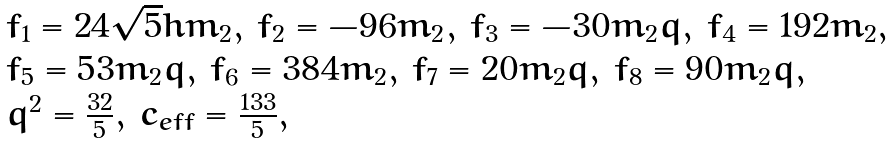<formula> <loc_0><loc_0><loc_500><loc_500>\begin{array} { l } f _ { 1 } = 2 4 \sqrt { 5 } h m _ { 2 } , \, f _ { 2 } = - 9 6 m _ { 2 } , \, f _ { 3 } = - 3 0 m _ { 2 } q , \, f _ { 4 } = 1 9 2 m _ { 2 } , \\ f _ { 5 } = 5 3 m _ { 2 } q , \, f _ { 6 } = 3 8 4 m _ { 2 } , \, f _ { 7 } = 2 0 m _ { 2 } q , \, f _ { 8 } = 9 0 m _ { 2 } q , \\ q ^ { 2 } = \frac { 3 2 } { 5 } , \, c _ { e f f } = \frac { 1 3 3 } { 5 } , \end{array}</formula> 